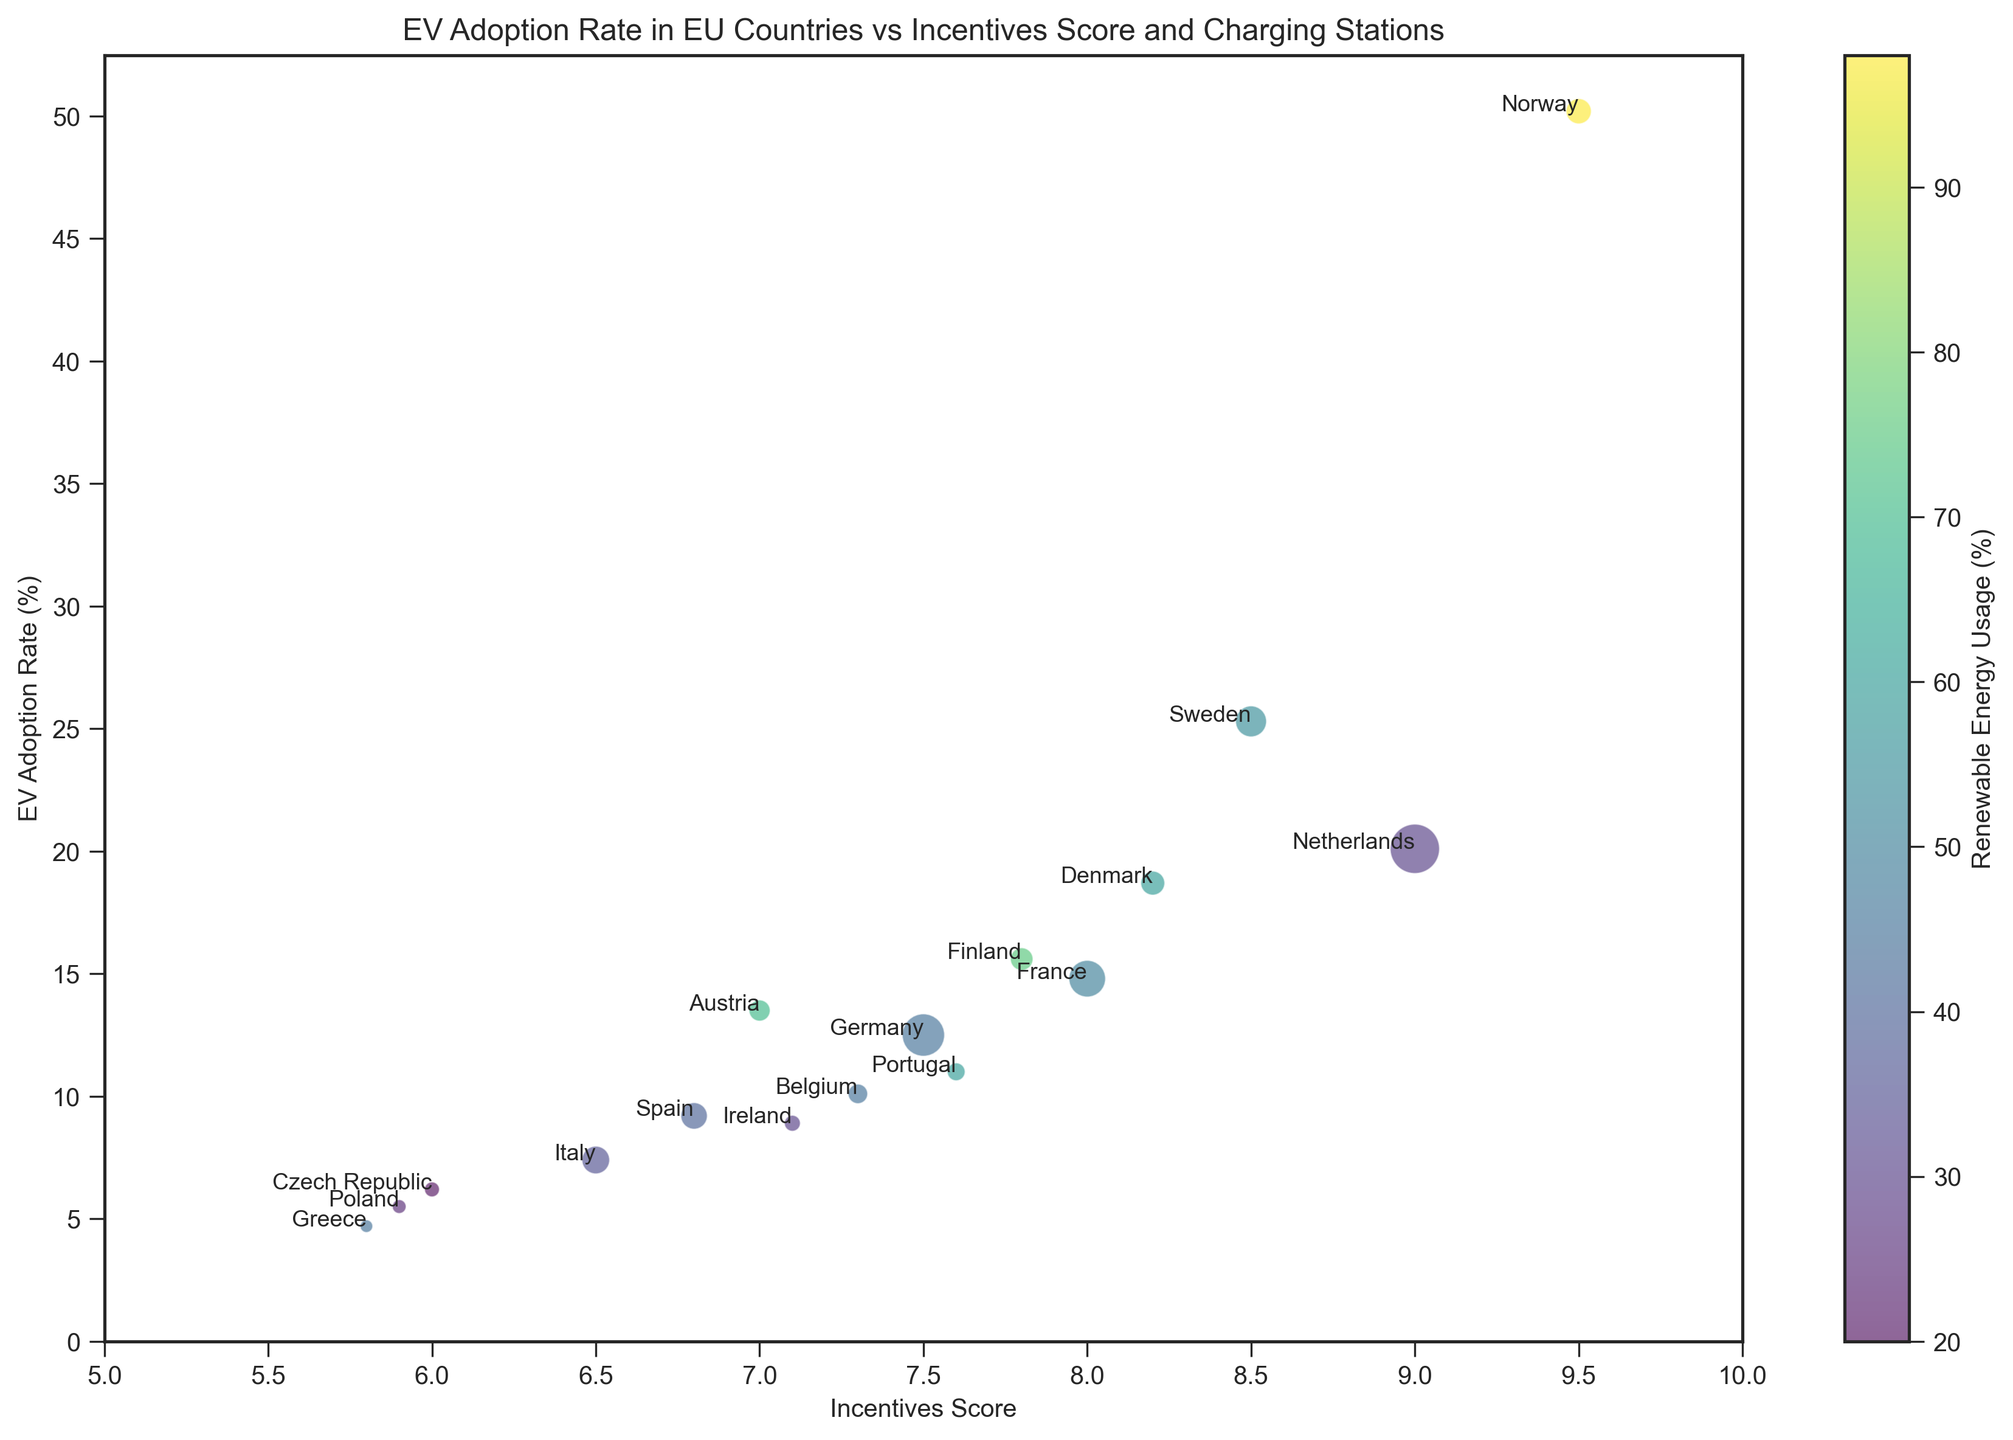What's the country with the highest EV adoption rate? First, identify the highest point on the y-axis representing EV adoption rate, then look for the corresponding country label. The highest point is approximately 50.2%, which is Norway.
Answer: Norway Which country has the most charging stations? Look for the largest bubble in the plot, since bubble size represents the number of charging stations. The largest bubble is for the Netherlands with 38,000 charging stations.
Answer: Netherlands What is the incentive score of the country with the lowest renewable energy usage? Identify the country at the lowest end of the color gradient (or lightest color), which represents renewable energy usage. The Czech Republic has the lowest renewable energy usage of 20%, and its incentive score is 6.0.
Answer: 6.0 Which countries have an incentives score greater than 8.0 and what are their renewable energy usages? Find the countries with incentives score markers positioned greater than 8.0 on the x-axis. These countries are Norway, Sweden, Denmark, and the Netherlands. Their respective renewable energy usages are 98%, 55%, 60%, and 30%.
Answer: Norway (98%), Sweden (55%), Denmark (60%), Netherlands (30%) What is the EV adoption rate difference between France and Finland? Identify the y-values for France (14.8%) and Finland (15.6%), then calculate their difference: 15.6% - 14.8% = 0.8%.
Answer: 0.8% How do the renewable energy usages of Denmark and Portugal compare? Identify the colors of the bubbles for Denmark and Portugal, which represent renewable energy usage. Denmark has 60% and Portugal has 60%, indicating they are equal.
Answer: They are equal at 60% Which country with an incentive score below 6.5 has the highest EV adoption rate? Look for countries on the figure with incentives scores below 6.5 on the x-axis, then identify the one with the highest y-value. The highest EV adoption rate in this group is Italy with 7.4%.
Answer: Italy Which countries have more than 10,000 charging stations but less than 50% renewable energy usage? Look for the countries with bubble sizes greater than that representing 10,000 charging stations and then cross-reference with their color gradient for renewable energy usage. Germany, France, Netherlands, Italy, Spain, and Belgium meet these criteria.
Answer: Germany, France, Netherlands, Italy, Spain, Belgium What is the average EV adoption rate among countries with incentives score between 7.0 and 8.0? Identify the countries within this incentive score range: Germany (12.5), Finland (15.6), Austria (13.5), Belgium (10.1), Ireland (8.9). Compute the average: (12.5 + 15.6 + 13.5 + 10.1 + 8.9) / 5 = 12.12%.
Answer: 12.12% How many countries have an EV adoption rate higher than 20%? Count the number of countries represented by markers above the 20% line on the y-axis. The countries are Netherlands, Norway, and Sweden, so there are 3 countries.
Answer: 3 